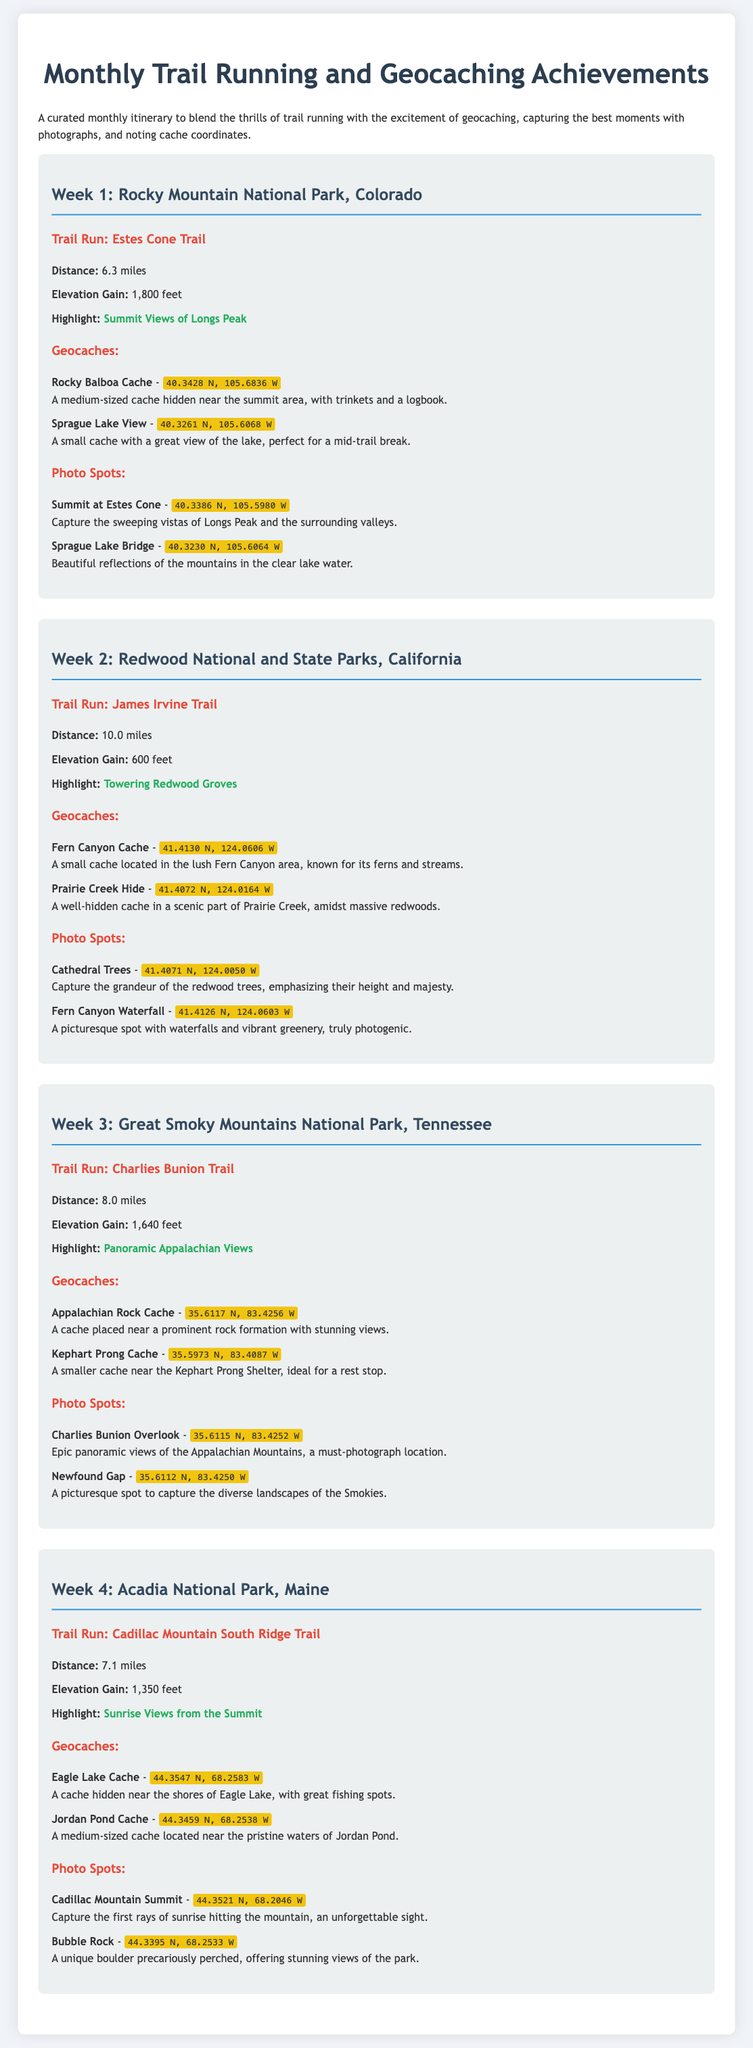What is the distance of the Estes Cone Trail? The document states that the distance of the Estes Cone Trail is 6.3 miles.
Answer: 6.3 miles What is the highlight of the James Irvine Trail? The highlight of the James Irvine Trail is the towering redwood groves as mentioned in the document.
Answer: Towering Redwood Groves What are the coordinates for the Appalachian Rock Cache? The document provides the coordinates for the Appalachian Rock Cache as 35.6117 N, 83.4256 W.
Answer: 35.6117 N, 83.4256 W How many miles is the Cadillac Mountain South Ridge Trail? The distance of the Cadillac Mountain South Ridge Trail is provided as 7.1 miles in the document.
Answer: 7.1 miles What is located near the coordinates 40.3386 N, 105.5980 W? The document lists the summit at Estes Cone as the photo spot located at those coordinates.
Answer: Summit at Estes Cone Which week features Trail Run: Charlies Bunion Trail? The document mentions that the Charlies Bunion Trail is featured in Week 3 of the itinerary.
Answer: Week 3 How many geocaches are listed for Redwood National and State Parks? The document provides two geocaches listed for Redwood National and State Parks.
Answer: Two What is the elevation gain of the Charlies Bunion Trail? The elevation gain for the Charlies Bunion Trail is given as 1,640 feet in the document.
Answer: 1,640 feet 